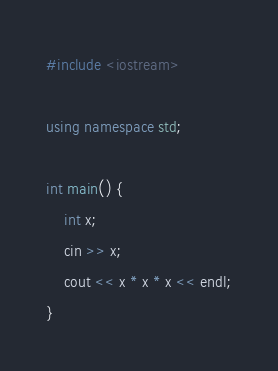<code> <loc_0><loc_0><loc_500><loc_500><_C++_>#include <iostream>

using namespace std;

int main() {
	int x;
	cin >> x;
	cout << x * x * x << endl;
}</code> 